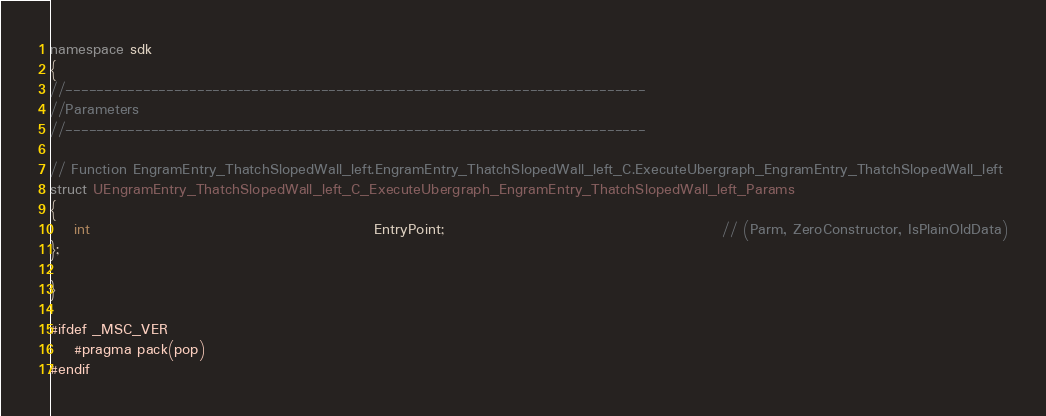Convert code to text. <code><loc_0><loc_0><loc_500><loc_500><_C++_>namespace sdk
{
//---------------------------------------------------------------------------
//Parameters
//---------------------------------------------------------------------------

// Function EngramEntry_ThatchSlopedWall_left.EngramEntry_ThatchSlopedWall_left_C.ExecuteUbergraph_EngramEntry_ThatchSlopedWall_left
struct UEngramEntry_ThatchSlopedWall_left_C_ExecuteUbergraph_EngramEntry_ThatchSlopedWall_left_Params
{
	int                                                EntryPoint;                                               // (Parm, ZeroConstructor, IsPlainOldData)
};

}

#ifdef _MSC_VER
	#pragma pack(pop)
#endif
</code> 